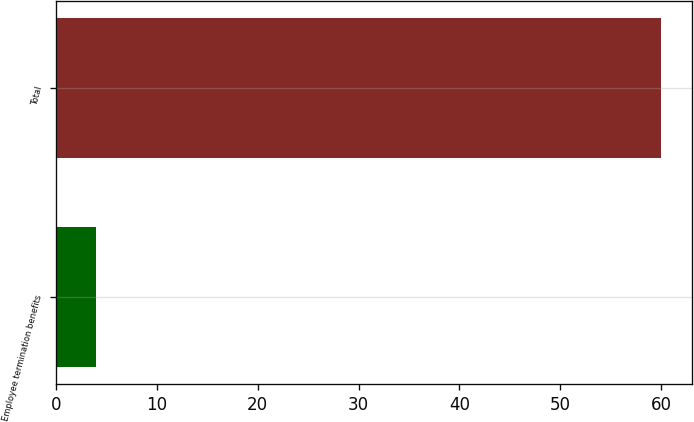Convert chart to OTSL. <chart><loc_0><loc_0><loc_500><loc_500><bar_chart><fcel>Employee termination benefits<fcel>Total<nl><fcel>4<fcel>60<nl></chart> 